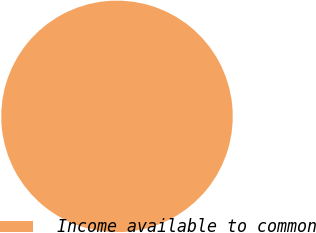Convert chart to OTSL. <chart><loc_0><loc_0><loc_500><loc_500><pie_chart><fcel>Income available to common<nl><fcel>100.0%<nl></chart> 